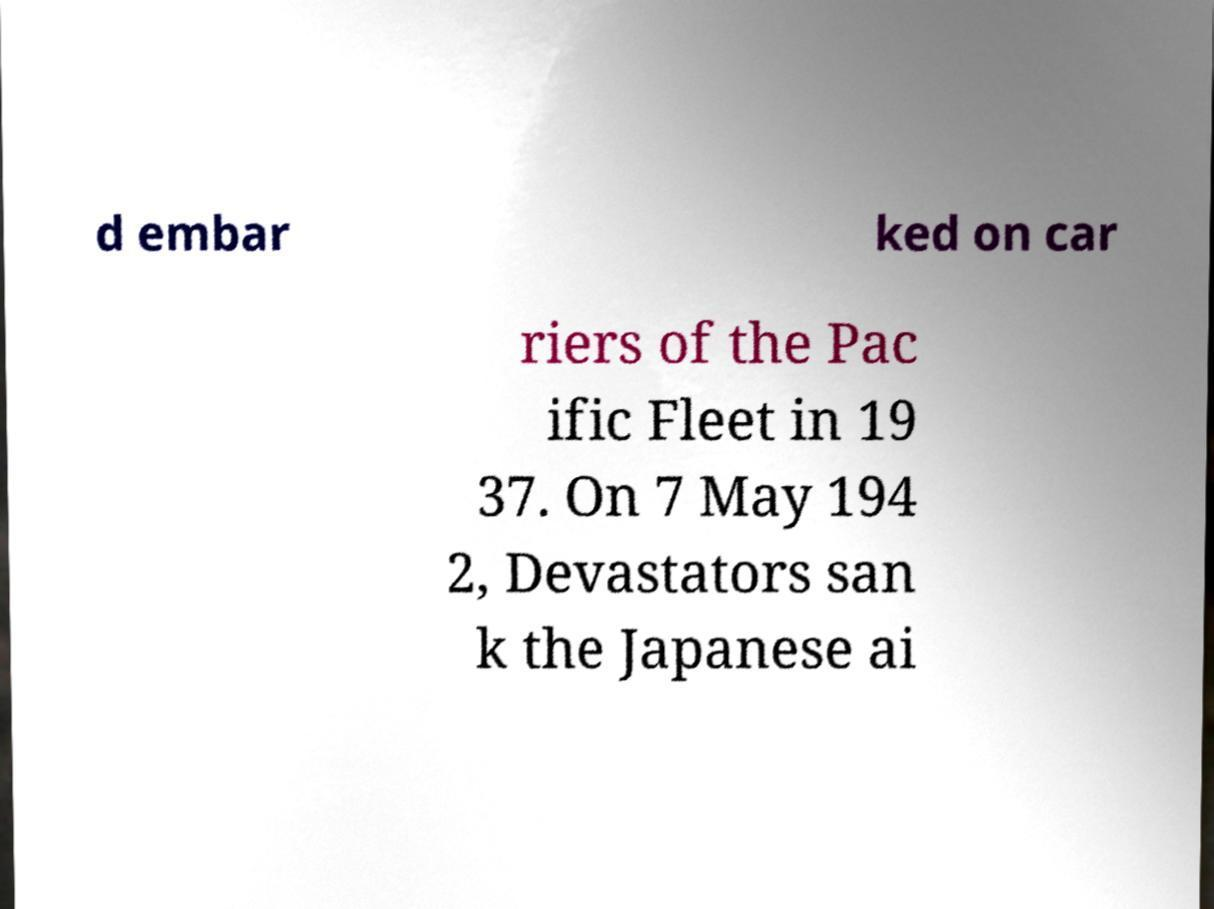Please read and relay the text visible in this image. What does it say? d embar ked on car riers of the Pac ific Fleet in 19 37. On 7 May 194 2, Devastators san k the Japanese ai 